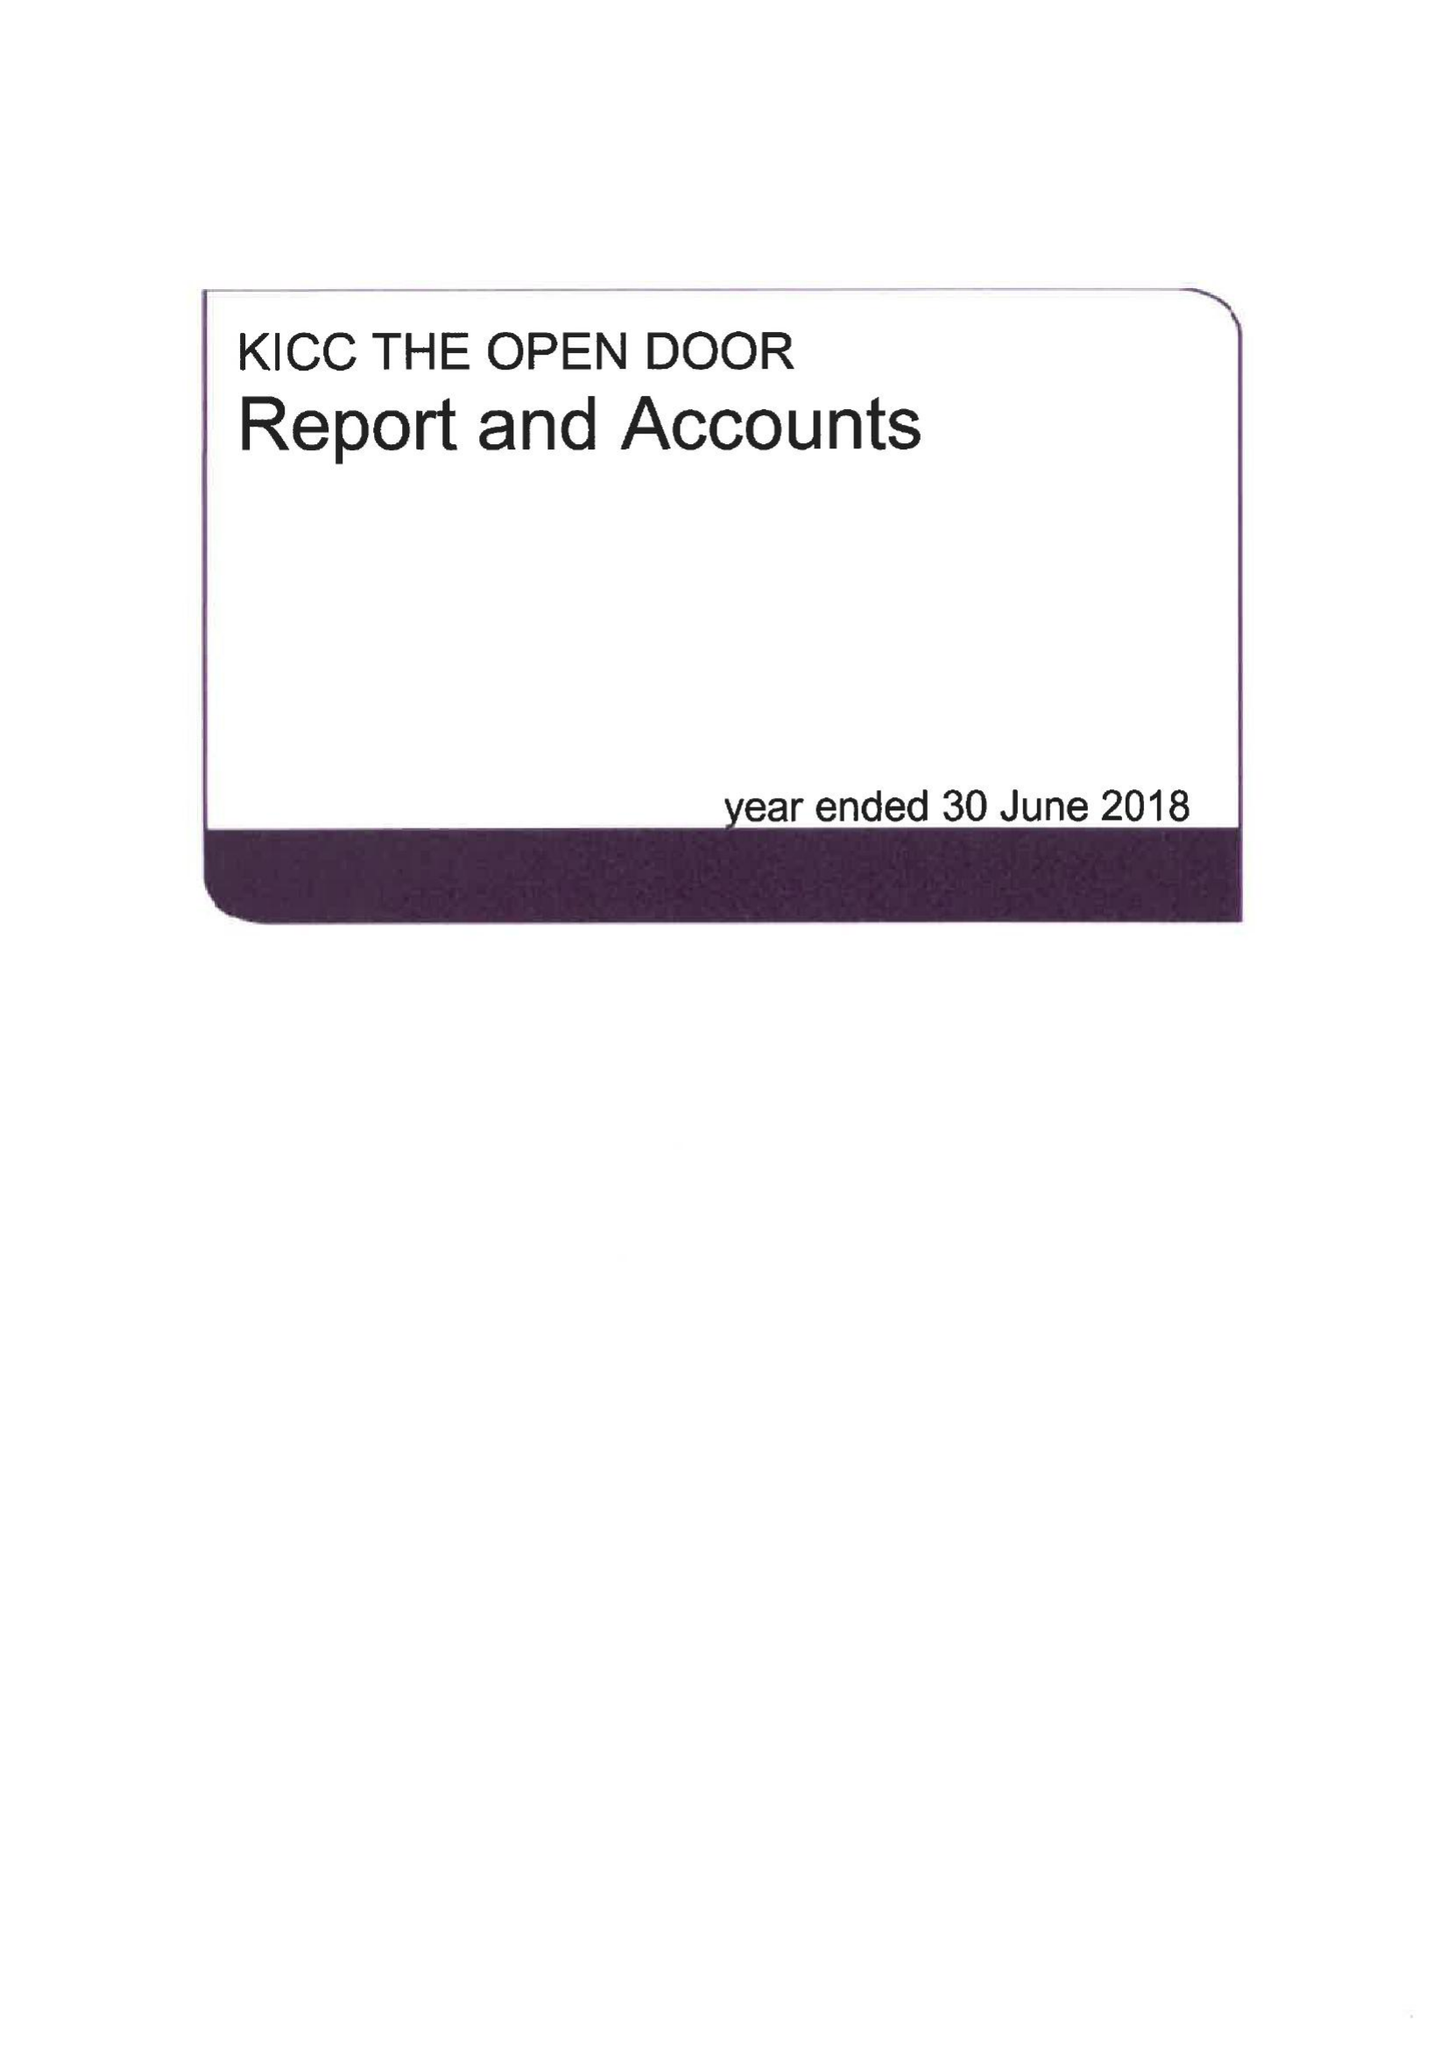What is the value for the income_annually_in_british_pounds?
Answer the question using a single word or phrase. 496371.00 